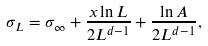Convert formula to latex. <formula><loc_0><loc_0><loc_500><loc_500>\sigma _ { L } = \sigma _ { \infty } + \frac { x \ln L } { 2 L ^ { d - 1 } } + \frac { \ln A } { 2 L ^ { d - 1 } } ,</formula> 